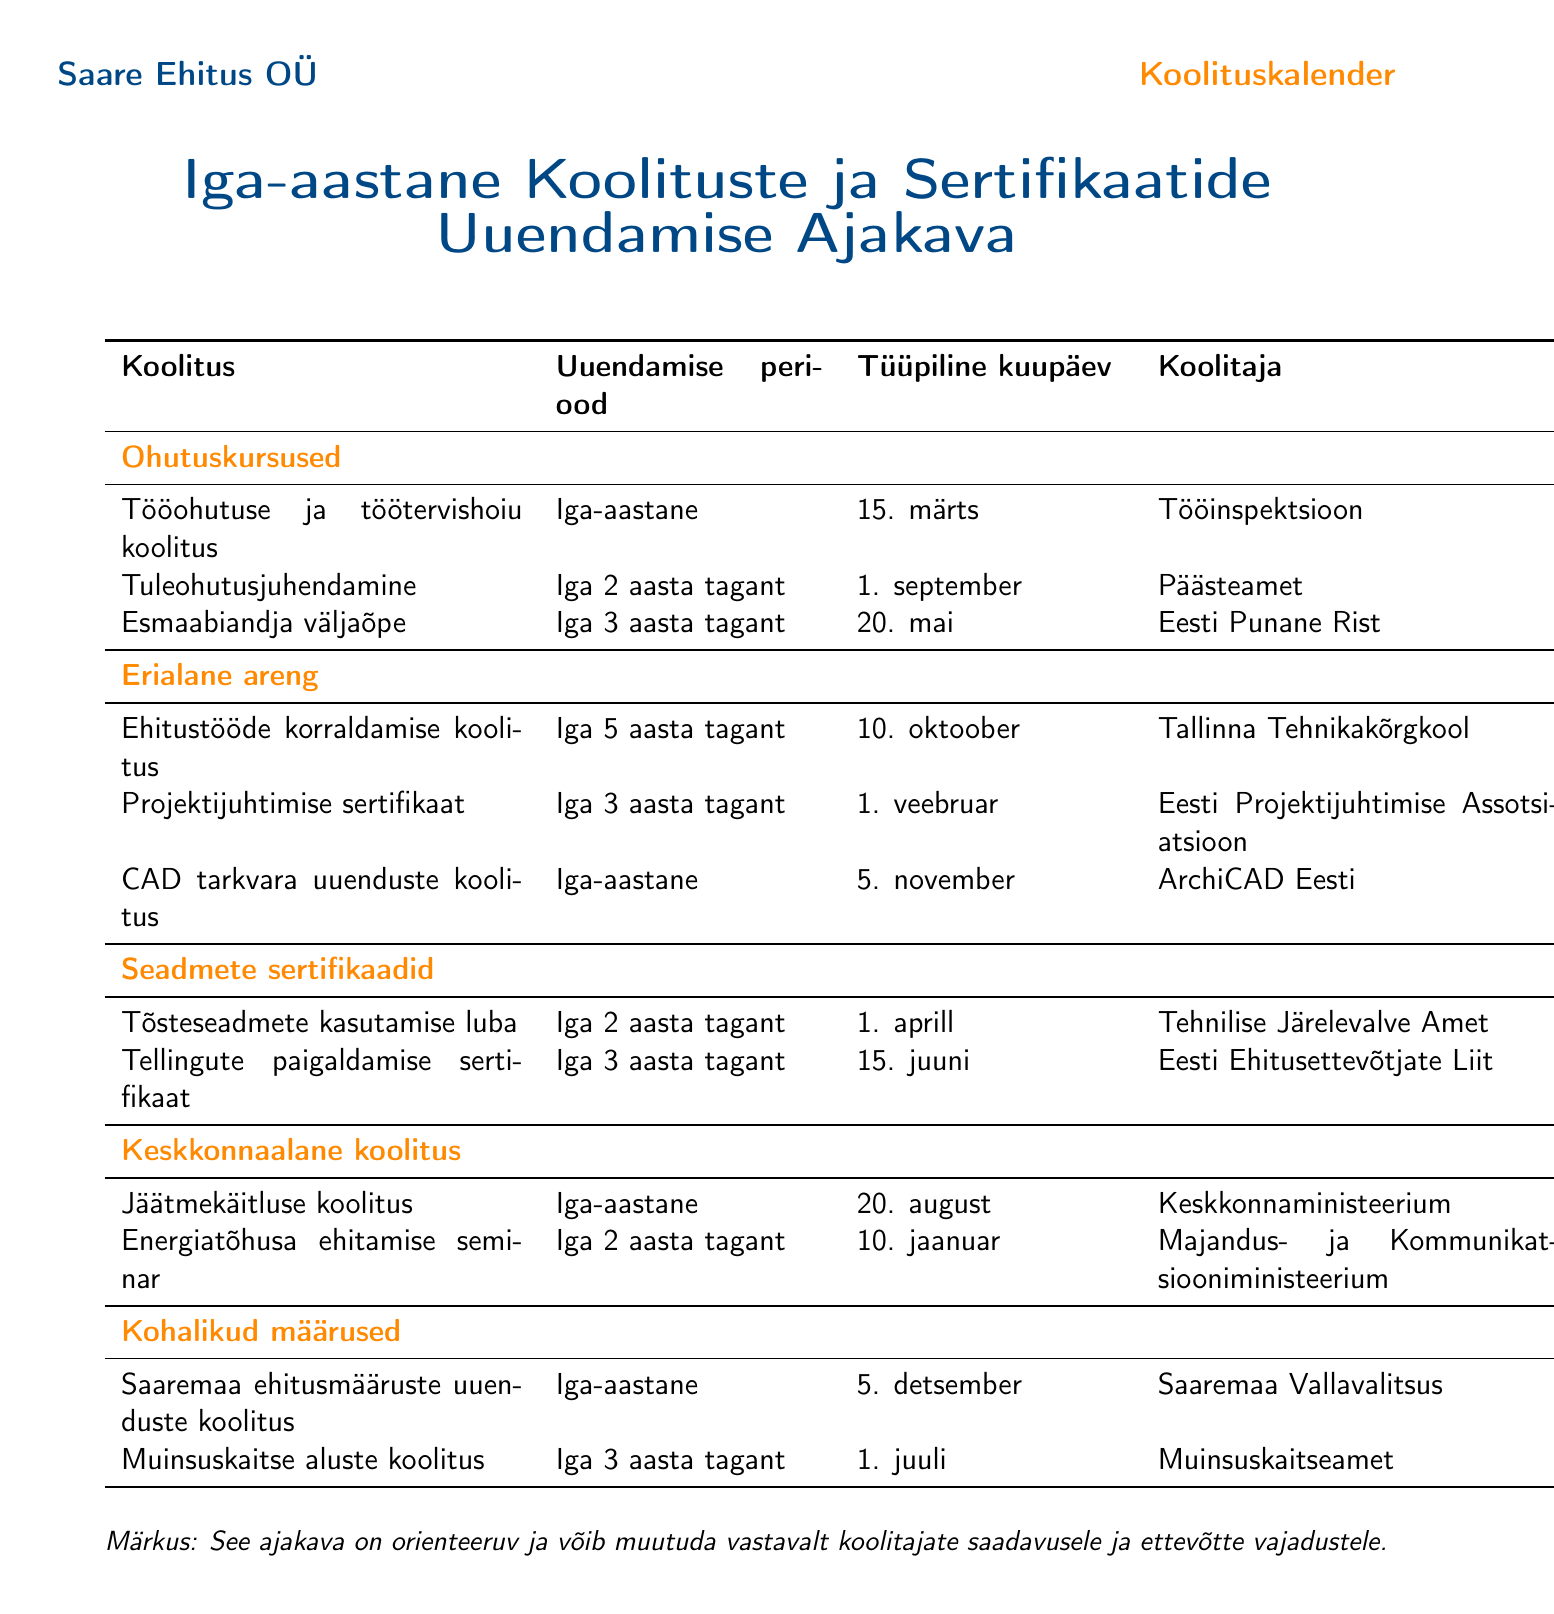what is the renewal period for "Tööohutuse ja töötervishoiu koolitus"? The renewal period indicates how often this training needs to be renewed, which is stated as "Annual."
Answer: Annual when is the typical date for "Esmaabiandja väljaõpe"? The typical date is clearly mentioned in the document, which states it as "May 20."
Answer: May 20 which provider offers "Projektijuhtimise sertifikaat"? The provider for this certification is specified in the table, identified as "Eesti Projektijuhtimise Assotsiatsioon."
Answer: Eesti Projektijuhtimise Assotsiatsioon how often must "Jäätmekäitluse koolitus" be renewed? The document specifies the renewal period as "Annual," indicating it should be renewed every year.
Answer: Annual what is the date for renewing the "Tellingute paigaldamise sertifikaat"? The document lists the renewal date as "June 15," which is the next renewal date for this certification.
Answer: June 15 which local regulations training is scheduled for December 5? The document lists "Saaremaa ehitusmääruste uuenduste koolitus" as the training scheduled for this date.
Answer: Saaremaa ehitusmääruste uuenduste koolitus how often does "Energiatõhusa ehitamise seminar" need to be renewed? The renewal frequency for this seminar is stated in the document as "Biennial," indicating a two-year period.
Answer: Biennial who is the provider for "Tuleohutusjuhendamine"? The document mentions "Päästeamet" as the provider for this safety course.
Answer: Päästeamet what is the deadline for "CAD tarkvara uuenduste koolitus"? According to the document, the deadline is listed as "November 5."
Answer: November 5 